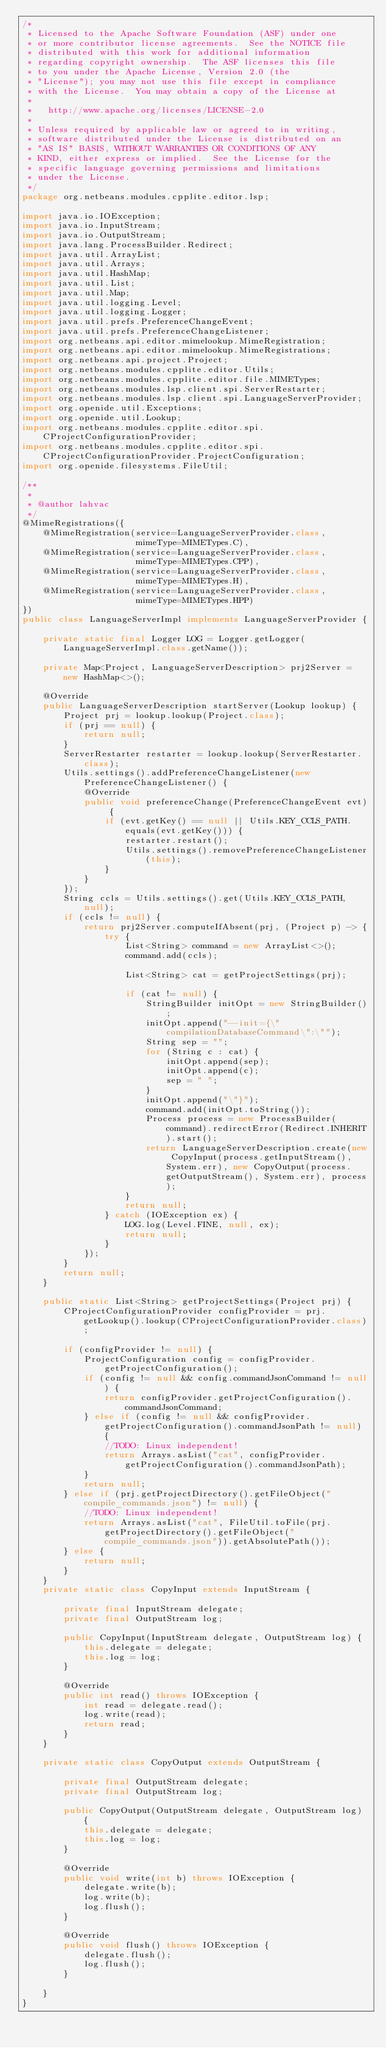Convert code to text. <code><loc_0><loc_0><loc_500><loc_500><_Java_>/*
 * Licensed to the Apache Software Foundation (ASF) under one
 * or more contributor license agreements.  See the NOTICE file
 * distributed with this work for additional information
 * regarding copyright ownership.  The ASF licenses this file
 * to you under the Apache License, Version 2.0 (the
 * "License"); you may not use this file except in compliance
 * with the License.  You may obtain a copy of the License at
 *
 *   http://www.apache.org/licenses/LICENSE-2.0
 *
 * Unless required by applicable law or agreed to in writing,
 * software distributed under the License is distributed on an
 * "AS IS" BASIS, WITHOUT WARRANTIES OR CONDITIONS OF ANY
 * KIND, either express or implied.  See the License for the
 * specific language governing permissions and limitations
 * under the License.
 */
package org.netbeans.modules.cpplite.editor.lsp;

import java.io.IOException;
import java.io.InputStream;
import java.io.OutputStream;
import java.lang.ProcessBuilder.Redirect;
import java.util.ArrayList;
import java.util.Arrays;
import java.util.HashMap;
import java.util.List;
import java.util.Map;
import java.util.logging.Level;
import java.util.logging.Logger;
import java.util.prefs.PreferenceChangeEvent;
import java.util.prefs.PreferenceChangeListener;
import org.netbeans.api.editor.mimelookup.MimeRegistration;
import org.netbeans.api.editor.mimelookup.MimeRegistrations;
import org.netbeans.api.project.Project;
import org.netbeans.modules.cpplite.editor.Utils;
import org.netbeans.modules.cpplite.editor.file.MIMETypes;
import org.netbeans.modules.lsp.client.spi.ServerRestarter;
import org.netbeans.modules.lsp.client.spi.LanguageServerProvider;
import org.openide.util.Exceptions;
import org.openide.util.Lookup;
import org.netbeans.modules.cpplite.editor.spi.CProjectConfigurationProvider;
import org.netbeans.modules.cpplite.editor.spi.CProjectConfigurationProvider.ProjectConfiguration;
import org.openide.filesystems.FileUtil;

/**
 *
 * @author lahvac
 */
@MimeRegistrations({
    @MimeRegistration(service=LanguageServerProvider.class,
                      mimeType=MIMETypes.C),
    @MimeRegistration(service=LanguageServerProvider.class,
                      mimeType=MIMETypes.CPP),
    @MimeRegistration(service=LanguageServerProvider.class,
                      mimeType=MIMETypes.H),
    @MimeRegistration(service=LanguageServerProvider.class,
                      mimeType=MIMETypes.HPP)
})
public class LanguageServerImpl implements LanguageServerProvider {

    private static final Logger LOG = Logger.getLogger(LanguageServerImpl.class.getName());

    private Map<Project, LanguageServerDescription> prj2Server = new HashMap<>();

    @Override
    public LanguageServerDescription startServer(Lookup lookup) {
        Project prj = lookup.lookup(Project.class);
        if (prj == null) {
            return null;
        }
        ServerRestarter restarter = lookup.lookup(ServerRestarter.class);
        Utils.settings().addPreferenceChangeListener(new PreferenceChangeListener() {
            @Override
            public void preferenceChange(PreferenceChangeEvent evt) {
                if (evt.getKey() == null || Utils.KEY_CCLS_PATH.equals(evt.getKey())) {
                    restarter.restart();
                    Utils.settings().removePreferenceChangeListener(this);
                }
            }
        });
        String ccls = Utils.settings().get(Utils.KEY_CCLS_PATH, null);
        if (ccls != null) {
            return prj2Server.computeIfAbsent(prj, (Project p) -> {
                try {
                    List<String> command = new ArrayList<>();
                    command.add(ccls);

                    List<String> cat = getProjectSettings(prj);

                    if (cat != null) {
                        StringBuilder initOpt = new StringBuilder();
                        initOpt.append("--init={\"compilationDatabaseCommand\":\"");
                        String sep = "";
                        for (String c : cat) {
                            initOpt.append(sep);
                            initOpt.append(c);
                            sep = " ";
                        }
                        initOpt.append("\"}");
                        command.add(initOpt.toString());
                        Process process = new ProcessBuilder(command).redirectError(Redirect.INHERIT).start();
                        return LanguageServerDescription.create(new CopyInput(process.getInputStream(), System.err), new CopyOutput(process.getOutputStream(), System.err), process);
                    }
                    return null;
                } catch (IOException ex) {
                    LOG.log(Level.FINE, null, ex);
                    return null;
                }
            });
        }
        return null;
    }
    
    public static List<String> getProjectSettings(Project prj) {
        CProjectConfigurationProvider configProvider = prj.getLookup().lookup(CProjectConfigurationProvider.class);

        if (configProvider != null) {
            ProjectConfiguration config = configProvider.getProjectConfiguration();
            if (config != null && config.commandJsonCommand != null) {
                return configProvider.getProjectConfiguration().commandJsonCommand;
            } else if (config != null && configProvider.getProjectConfiguration().commandJsonPath != null) {
                //TODO: Linux independent!
                return Arrays.asList("cat", configProvider.getProjectConfiguration().commandJsonPath);
            }
            return null;
        } else if (prj.getProjectDirectory().getFileObject("compile_commands.json") != null) {
            //TODO: Linux independent!
            return Arrays.asList("cat", FileUtil.toFile(prj.getProjectDirectory().getFileObject("compile_commands.json")).getAbsolutePath());
        } else {
            return null;
        }
    }
    private static class CopyInput extends InputStream {

        private final InputStream delegate;
        private final OutputStream log;

        public CopyInput(InputStream delegate, OutputStream log) {
            this.delegate = delegate;
            this.log = log;
        }

        @Override
        public int read() throws IOException {
            int read = delegate.read();
            log.write(read);
            return read;
        }
    }
    
    private static class CopyOutput extends OutputStream {

        private final OutputStream delegate;
        private final OutputStream log;

        public CopyOutput(OutputStream delegate, OutputStream log) {
            this.delegate = delegate;
            this.log = log;
        }

        @Override
        public void write(int b) throws IOException {
            delegate.write(b);
            log.write(b);
            log.flush();
        }

        @Override
        public void flush() throws IOException {
            delegate.flush();
            log.flush();
        }
        
    }
}
</code> 